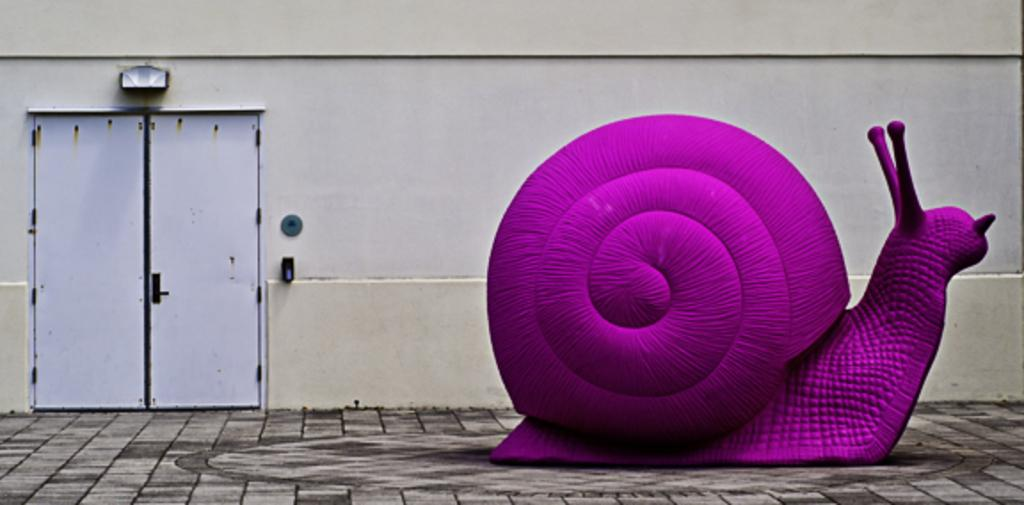What type of structure can be seen on the ground in the image? There is a snail-like structure on the ground in the image. Where is the snail-like structure located in the image? The snail-like structure is on the right side of the image. What type of architectural feature is present in the image? There is a door present in the image. Where is the door located in the image? The door is on the left side of the image. What type of lip can be seen on the snail-like structure in the image? There is no lip present on the snail-like structure in the image. 